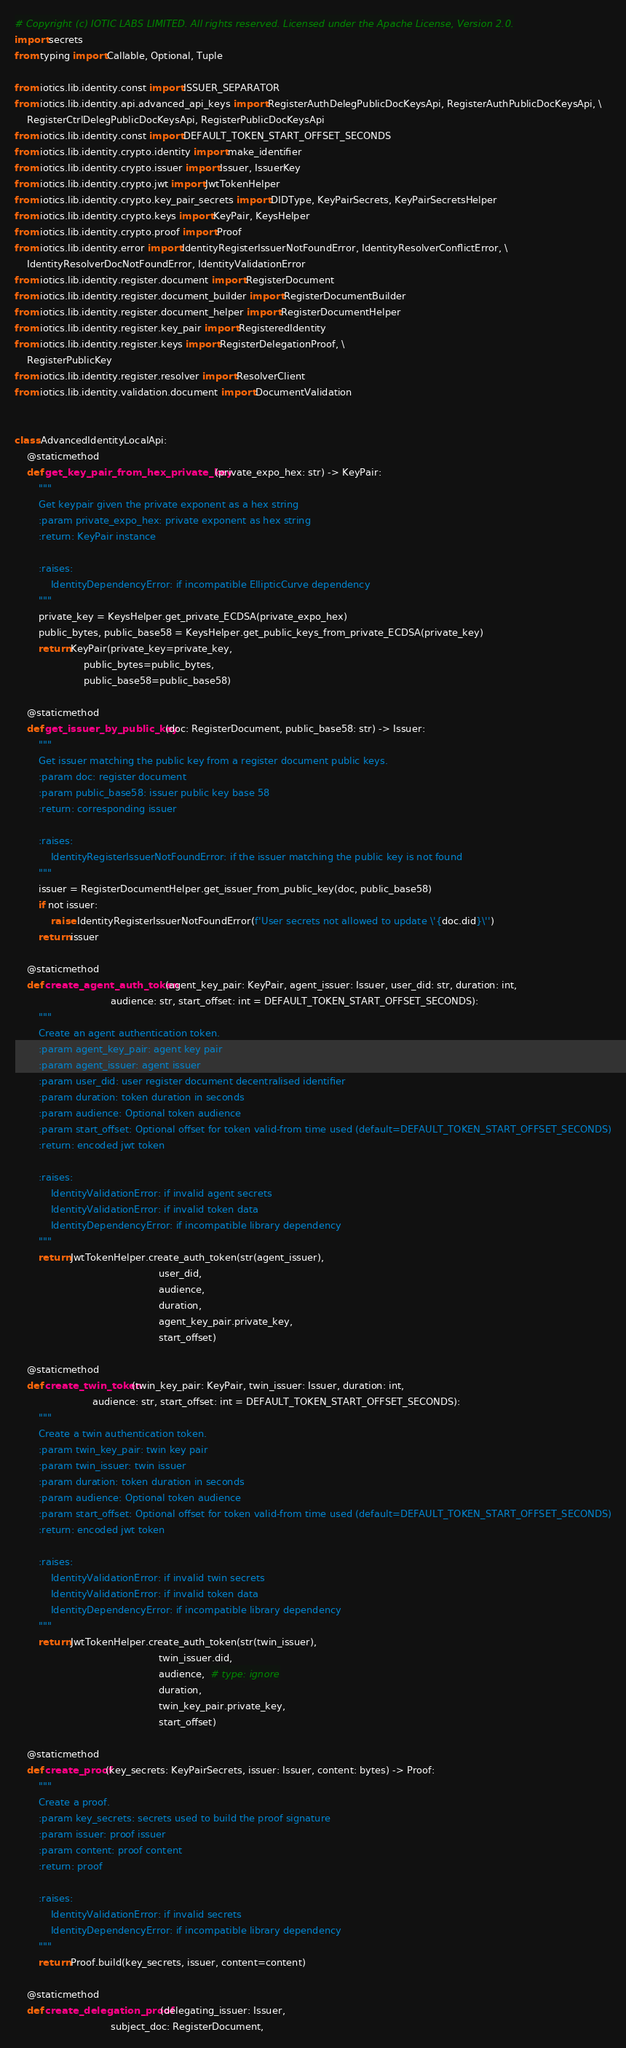<code> <loc_0><loc_0><loc_500><loc_500><_Python_># Copyright (c) IOTIC LABS LIMITED. All rights reserved. Licensed under the Apache License, Version 2.0.
import secrets
from typing import Callable, Optional, Tuple

from iotics.lib.identity.const import ISSUER_SEPARATOR
from iotics.lib.identity.api.advanced_api_keys import RegisterAuthDelegPublicDocKeysApi, RegisterAuthPublicDocKeysApi, \
    RegisterCtrlDelegPublicDocKeysApi, RegisterPublicDocKeysApi
from iotics.lib.identity.const import DEFAULT_TOKEN_START_OFFSET_SECONDS
from iotics.lib.identity.crypto.identity import make_identifier
from iotics.lib.identity.crypto.issuer import Issuer, IssuerKey
from iotics.lib.identity.crypto.jwt import JwtTokenHelper
from iotics.lib.identity.crypto.key_pair_secrets import DIDType, KeyPairSecrets, KeyPairSecretsHelper
from iotics.lib.identity.crypto.keys import KeyPair, KeysHelper
from iotics.lib.identity.crypto.proof import Proof
from iotics.lib.identity.error import IdentityRegisterIssuerNotFoundError, IdentityResolverConflictError, \
    IdentityResolverDocNotFoundError, IdentityValidationError
from iotics.lib.identity.register.document import RegisterDocument
from iotics.lib.identity.register.document_builder import RegisterDocumentBuilder
from iotics.lib.identity.register.document_helper import RegisterDocumentHelper
from iotics.lib.identity.register.key_pair import RegisteredIdentity
from iotics.lib.identity.register.keys import RegisterDelegationProof, \
    RegisterPublicKey
from iotics.lib.identity.register.resolver import ResolverClient
from iotics.lib.identity.validation.document import DocumentValidation


class AdvancedIdentityLocalApi:
    @staticmethod
    def get_key_pair_from_hex_private_key(private_expo_hex: str) -> KeyPair:
        """
        Get keypair given the private exponent as a hex string
        :param private_expo_hex: private exponent as hex string
        :return: KeyPair instance

        :raises:
            IdentityDependencyError: if incompatible EllipticCurve dependency
        """
        private_key = KeysHelper.get_private_ECDSA(private_expo_hex)
        public_bytes, public_base58 = KeysHelper.get_public_keys_from_private_ECDSA(private_key)
        return KeyPair(private_key=private_key,
                       public_bytes=public_bytes,
                       public_base58=public_base58)

    @staticmethod
    def get_issuer_by_public_key(doc: RegisterDocument, public_base58: str) -> Issuer:
        """
        Get issuer matching the public key from a register document public keys.
        :param doc: register document
        :param public_base58: issuer public key base 58
        :return: corresponding issuer

        :raises:
            IdentityRegisterIssuerNotFoundError: if the issuer matching the public key is not found
        """
        issuer = RegisterDocumentHelper.get_issuer_from_public_key(doc, public_base58)
        if not issuer:
            raise IdentityRegisterIssuerNotFoundError(f'User secrets not allowed to update \'{doc.did}\'')
        return issuer

    @staticmethod
    def create_agent_auth_token(agent_key_pair: KeyPair, agent_issuer: Issuer, user_did: str, duration: int,
                                audience: str, start_offset: int = DEFAULT_TOKEN_START_OFFSET_SECONDS):
        """
        Create an agent authentication token.
        :param agent_key_pair: agent key pair
        :param agent_issuer: agent issuer
        :param user_did: user register document decentralised identifier
        :param duration: token duration in seconds
        :param audience: Optional token audience
        :param start_offset: Optional offset for token valid-from time used (default=DEFAULT_TOKEN_START_OFFSET_SECONDS)
        :return: encoded jwt token

        :raises:
            IdentityValidationError: if invalid agent secrets
            IdentityValidationError: if invalid token data
            IdentityDependencyError: if incompatible library dependency
        """
        return JwtTokenHelper.create_auth_token(str(agent_issuer),
                                                user_did,
                                                audience,
                                                duration,
                                                agent_key_pair.private_key,
                                                start_offset)

    @staticmethod
    def create_twin_token(twin_key_pair: KeyPair, twin_issuer: Issuer, duration: int,
                          audience: str, start_offset: int = DEFAULT_TOKEN_START_OFFSET_SECONDS):
        """
        Create a twin authentication token.
        :param twin_key_pair: twin key pair
        :param twin_issuer: twin issuer
        :param duration: token duration in seconds
        :param audience: Optional token audience
        :param start_offset: Optional offset for token valid-from time used (default=DEFAULT_TOKEN_START_OFFSET_SECONDS)
        :return: encoded jwt token

        :raises:
            IdentityValidationError: if invalid twin secrets
            IdentityValidationError: if invalid token data
            IdentityDependencyError: if incompatible library dependency
        """
        return JwtTokenHelper.create_auth_token(str(twin_issuer),
                                                twin_issuer.did,
                                                audience,  # type: ignore
                                                duration,
                                                twin_key_pair.private_key,
                                                start_offset)

    @staticmethod
    def create_proof(key_secrets: KeyPairSecrets, issuer: Issuer, content: bytes) -> Proof:
        """
        Create a proof.
        :param key_secrets: secrets used to build the proof signature
        :param issuer: proof issuer
        :param content: proof content
        :return: proof

        :raises:
            IdentityValidationError: if invalid secrets
            IdentityDependencyError: if incompatible library dependency
        """
        return Proof.build(key_secrets, issuer, content=content)

    @staticmethod
    def create_delegation_proof(delegating_issuer: Issuer,
                                subject_doc: RegisterDocument,</code> 